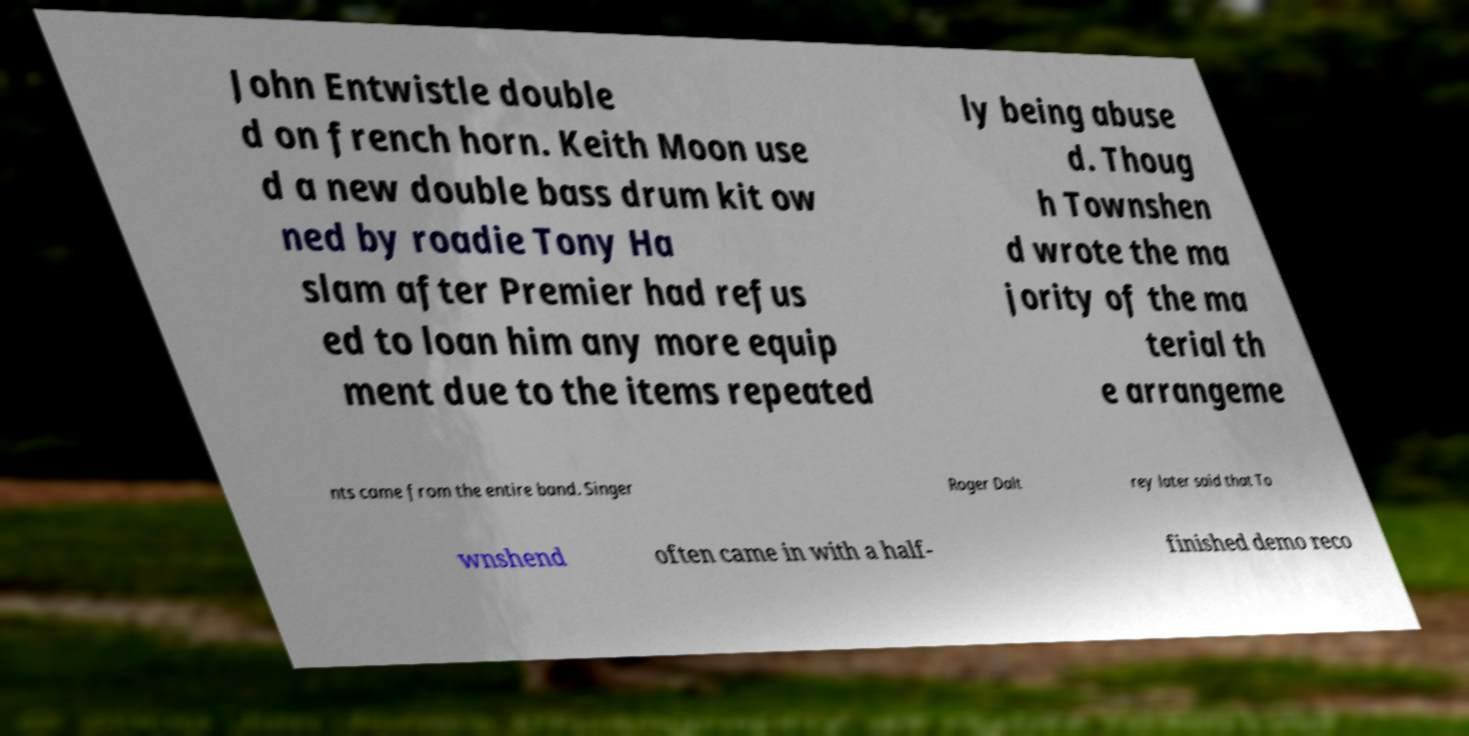For documentation purposes, I need the text within this image transcribed. Could you provide that? John Entwistle double d on french horn. Keith Moon use d a new double bass drum kit ow ned by roadie Tony Ha slam after Premier had refus ed to loan him any more equip ment due to the items repeated ly being abuse d. Thoug h Townshen d wrote the ma jority of the ma terial th e arrangeme nts came from the entire band. Singer Roger Dalt rey later said that To wnshend often came in with a half- finished demo reco 